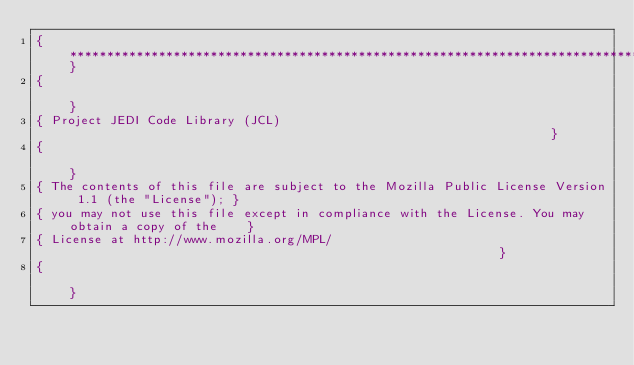Convert code to text. <code><loc_0><loc_0><loc_500><loc_500><_Pascal_>{**************************************************************************************************}
{                                                                                                  }
{ Project JEDI Code Library (JCL)                                                                  }
{                                                                                                  }
{ The contents of this file are subject to the Mozilla Public License Version 1.1 (the "License"); }
{ you may not use this file except in compliance with the License. You may obtain a copy of the    }
{ License at http://www.mozilla.org/MPL/                                                           }
{                                                                                                  }</code> 